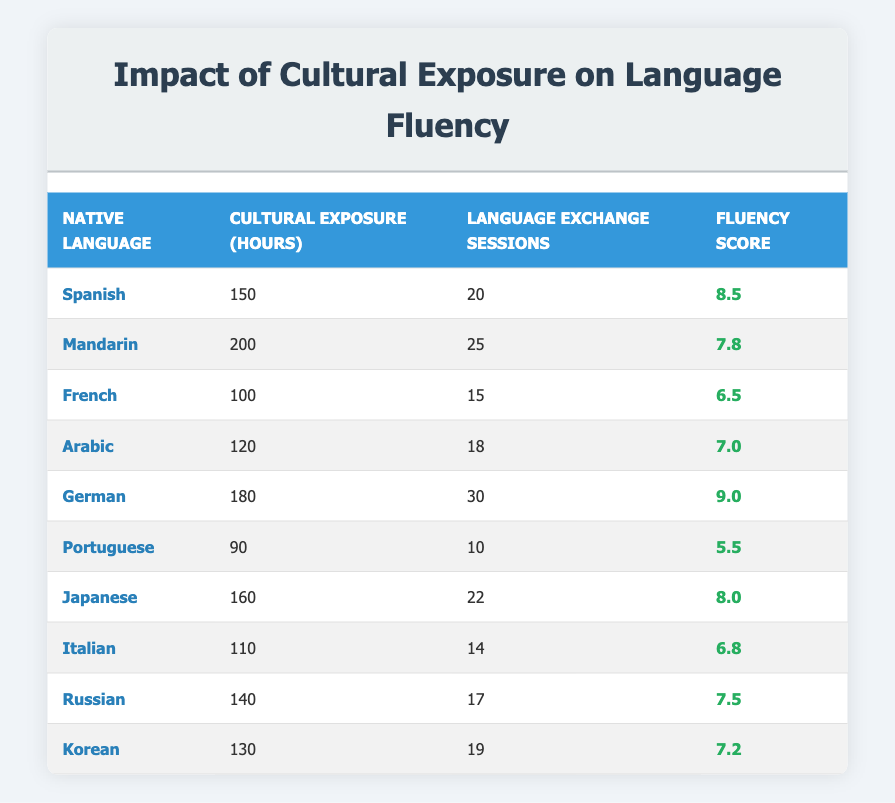What is the fluency score of the student whose native language is German? The student's entry for German shows a fluency score of 9.0 in the table.
Answer: 9.0 How many cultural exposure hours does the student with the highest fluency score have? The table reveals that the student with the highest fluency score, who speaks German, has 180 cultural exposure hours.
Answer: 180 Which student had the least fluency score? By scanning the table, we see the lowest fluency score is 5.5, associated with the student whose native language is Portuguese.
Answer: Portuguese What is the average fluency score of students who had more than 150 cultural exposure hours? The students with more than 150 cultural exposure hours are Spanish, Mandarin, German, Japanese, and Russian. Their scores are 8.5, 7.8, 9.0, 8.0, and 7.5. Adding these gives a total of 40.8, and dividing by the 5 students gives an average of 8.16.
Answer: 8.16 Is there a student who had exactly 120 cultural exposure hours? Looking through the table, we see that there is a student who speaks Arabic with exactly 120 cultural exposure hours.
Answer: Yes Which language exchange sessions did the student with the second-highest cultural exposure hours participate in? The student with the second-highest cultural exposure hours is the Mandarin student with 200 hours, who participated in 25 language exchange sessions.
Answer: 25 What is the difference in fluency scores between the highest and lowest-ranked students? The highest fluency score is 9.0 (German), and the lowest is 5.5 (Portuguese). The difference is calculated as 9.0 - 5.5 = 3.5.
Answer: 3.5 How many students had cultural exposure hours less than 100? Checking the table, we can see that only one student, who speaks Portuguese, had less than 100 cultural exposure hours, specifically 90 hours.
Answer: 1 If the average cultural exposure hours for all students is calculated, what is it? First, we add all cultural exposure hours: 150 + 200 + 100 + 120 + 180 + 90 + 160 + 110 + 140 + 130 = 1,470. We then divide by 10 (the number of students), which gives us an average of 147.
Answer: 147 